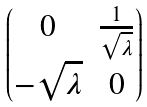<formula> <loc_0><loc_0><loc_500><loc_500>\begin{pmatrix} 0 & \frac { 1 } { \sqrt { \lambda } } \\ - \sqrt { \lambda } & 0 \end{pmatrix}</formula> 